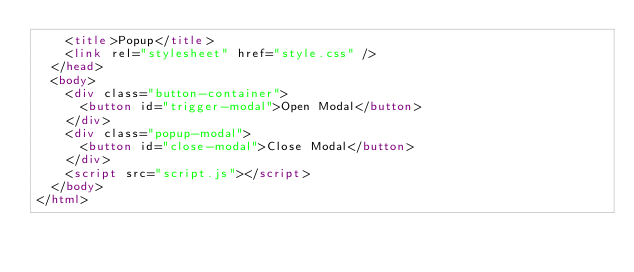<code> <loc_0><loc_0><loc_500><loc_500><_HTML_>    <title>Popup</title>
    <link rel="stylesheet" href="style.css" />
  </head>
  <body>
    <div class="button-container">
      <button id="trigger-modal">Open Modal</button>
    </div>
    <div class="popup-modal">
      <button id="close-modal">Close Modal</button>
    </div>
    <script src="script.js"></script>
  </body>
</html>
</code> 